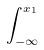<formula> <loc_0><loc_0><loc_500><loc_500>\int _ { - \infty } ^ { x _ { 1 } }</formula> 